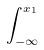<formula> <loc_0><loc_0><loc_500><loc_500>\int _ { - \infty } ^ { x _ { 1 } }</formula> 